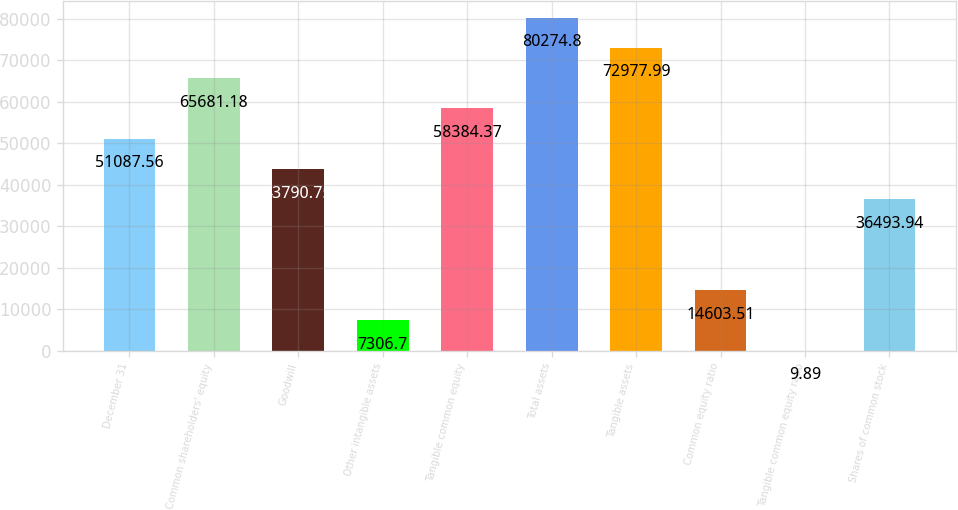<chart> <loc_0><loc_0><loc_500><loc_500><bar_chart><fcel>December 31<fcel>Common shareholders' equity<fcel>Goodwill<fcel>Other intangible assets<fcel>Tangible common equity<fcel>Total assets<fcel>Tangible assets<fcel>Common equity ratio<fcel>Tangible common equity ratio<fcel>Shares of common stock<nl><fcel>51087.6<fcel>65681.2<fcel>43790.8<fcel>7306.7<fcel>58384.4<fcel>80274.8<fcel>72978<fcel>14603.5<fcel>9.89<fcel>36493.9<nl></chart> 